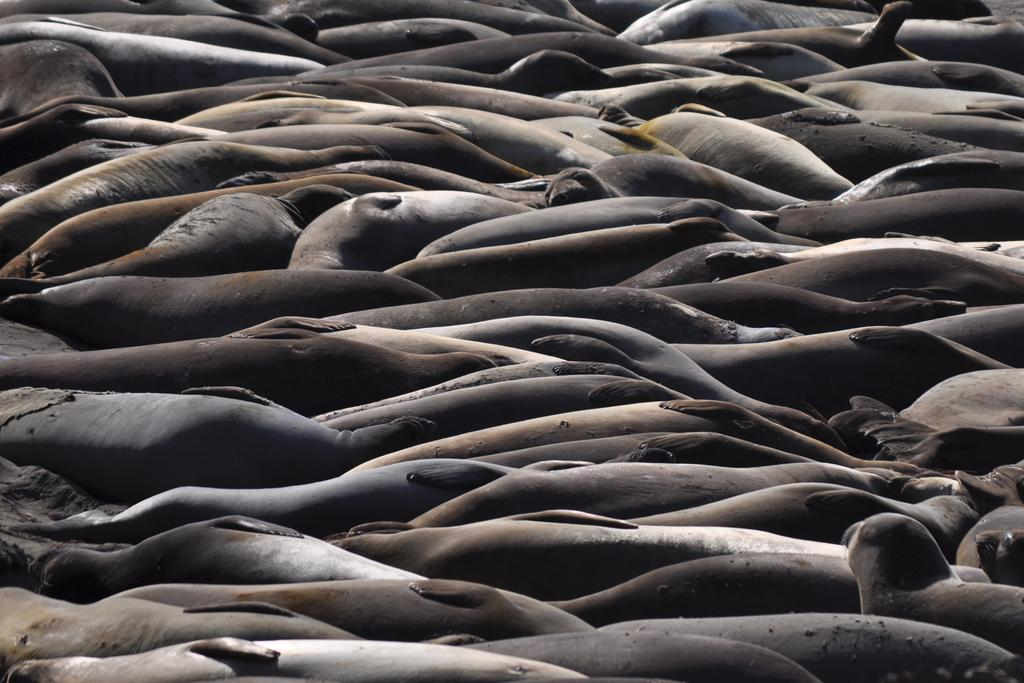What type of animals are present in the image? There are seals in the image. What brand of toothpaste is being used by the seals in the image? There is no toothpaste present in the image, as it features seals and not any human-related products. 